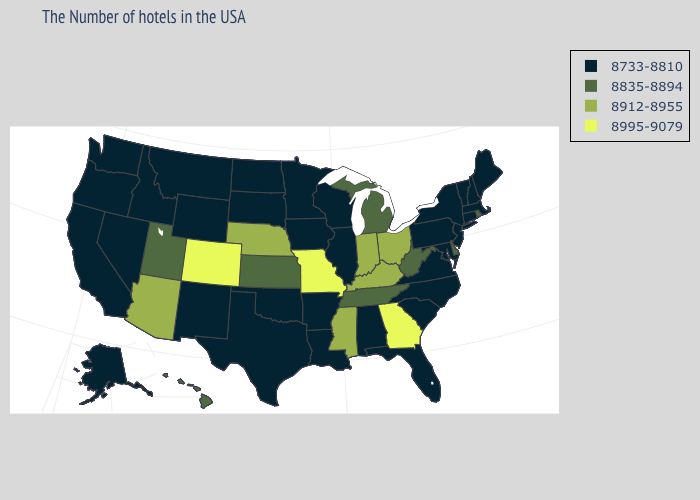Does Kansas have a lower value than Indiana?
Give a very brief answer. Yes. What is the value of Florida?
Concise answer only. 8733-8810. Name the states that have a value in the range 8835-8894?
Short answer required. Rhode Island, Delaware, West Virginia, Michigan, Tennessee, Kansas, Utah, Hawaii. What is the lowest value in states that border Maine?
Quick response, please. 8733-8810. Which states have the lowest value in the USA?
Give a very brief answer. Maine, Massachusetts, New Hampshire, Vermont, Connecticut, New York, New Jersey, Maryland, Pennsylvania, Virginia, North Carolina, South Carolina, Florida, Alabama, Wisconsin, Illinois, Louisiana, Arkansas, Minnesota, Iowa, Oklahoma, Texas, South Dakota, North Dakota, Wyoming, New Mexico, Montana, Idaho, Nevada, California, Washington, Oregon, Alaska. Does the map have missing data?
Quick response, please. No. What is the value of New Jersey?
Keep it brief. 8733-8810. What is the highest value in the South ?
Write a very short answer. 8995-9079. What is the value of New Hampshire?
Answer briefly. 8733-8810. What is the value of Virginia?
Concise answer only. 8733-8810. How many symbols are there in the legend?
Answer briefly. 4. Does Colorado have the highest value in the West?
Short answer required. Yes. What is the value of Connecticut?
Be succinct. 8733-8810. Does the map have missing data?
Concise answer only. No. What is the highest value in states that border Missouri?
Be succinct. 8912-8955. 